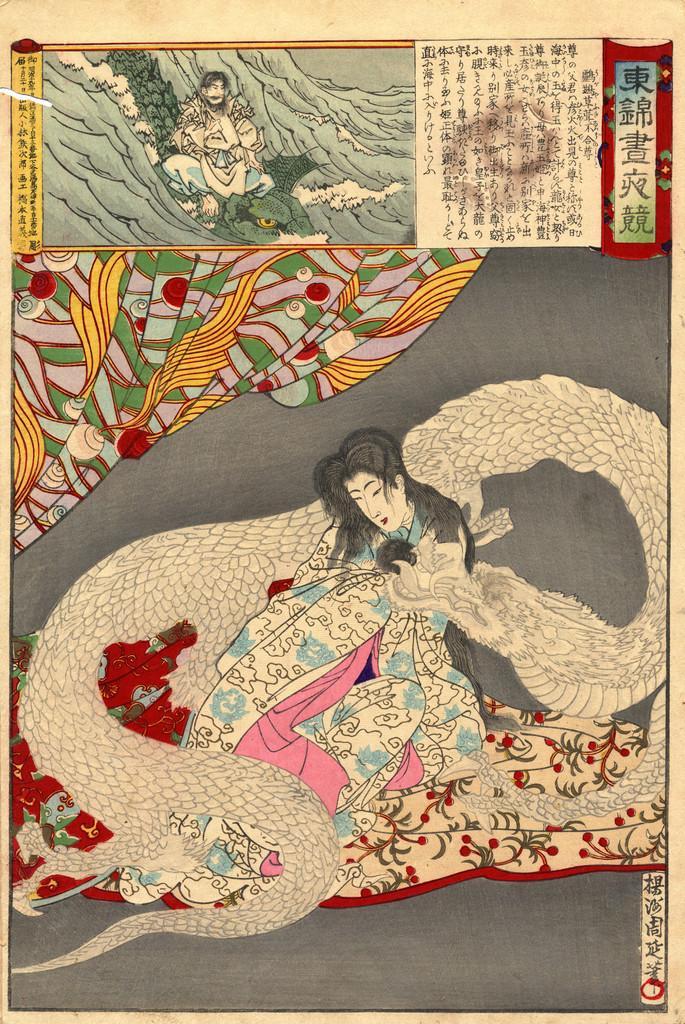Could you give a brief overview of what you see in this image? This is a poster and in this poster we can see two people, dragon snake, clothes, some objects and some text. 